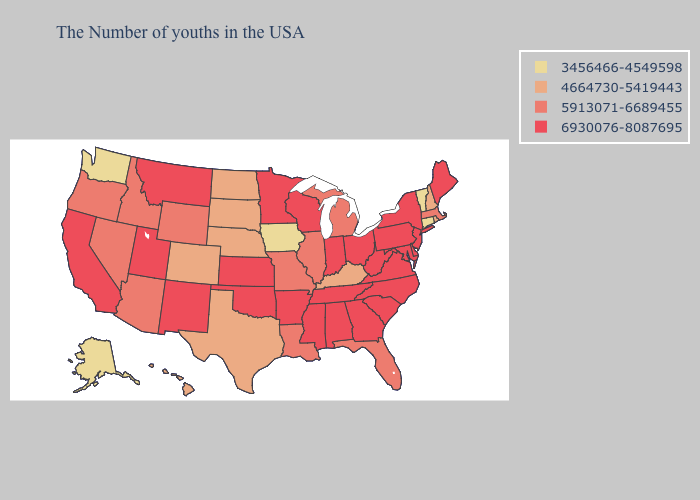Does Alabama have the same value as Texas?
Concise answer only. No. What is the highest value in the USA?
Answer briefly. 6930076-8087695. Name the states that have a value in the range 5913071-6689455?
Concise answer only. Massachusetts, Florida, Michigan, Illinois, Louisiana, Missouri, Wyoming, Arizona, Idaho, Nevada, Oregon. What is the value of Colorado?
Write a very short answer. 4664730-5419443. Is the legend a continuous bar?
Quick response, please. No. Does the first symbol in the legend represent the smallest category?
Keep it brief. Yes. What is the value of North Dakota?
Be succinct. 4664730-5419443. Which states have the lowest value in the MidWest?
Short answer required. Iowa. Which states have the lowest value in the USA?
Write a very short answer. Vermont, Connecticut, Iowa, Washington, Alaska. Does Illinois have a higher value than Hawaii?
Concise answer only. Yes. Name the states that have a value in the range 6930076-8087695?
Quick response, please. Maine, New York, New Jersey, Delaware, Maryland, Pennsylvania, Virginia, North Carolina, South Carolina, West Virginia, Ohio, Georgia, Indiana, Alabama, Tennessee, Wisconsin, Mississippi, Arkansas, Minnesota, Kansas, Oklahoma, New Mexico, Utah, Montana, California. Name the states that have a value in the range 5913071-6689455?
Write a very short answer. Massachusetts, Florida, Michigan, Illinois, Louisiana, Missouri, Wyoming, Arizona, Idaho, Nevada, Oregon. Name the states that have a value in the range 4664730-5419443?
Keep it brief. Rhode Island, New Hampshire, Kentucky, Nebraska, Texas, South Dakota, North Dakota, Colorado, Hawaii. Which states have the highest value in the USA?
Be succinct. Maine, New York, New Jersey, Delaware, Maryland, Pennsylvania, Virginia, North Carolina, South Carolina, West Virginia, Ohio, Georgia, Indiana, Alabama, Tennessee, Wisconsin, Mississippi, Arkansas, Minnesota, Kansas, Oklahoma, New Mexico, Utah, Montana, California. What is the lowest value in the USA?
Answer briefly. 3456466-4549598. 